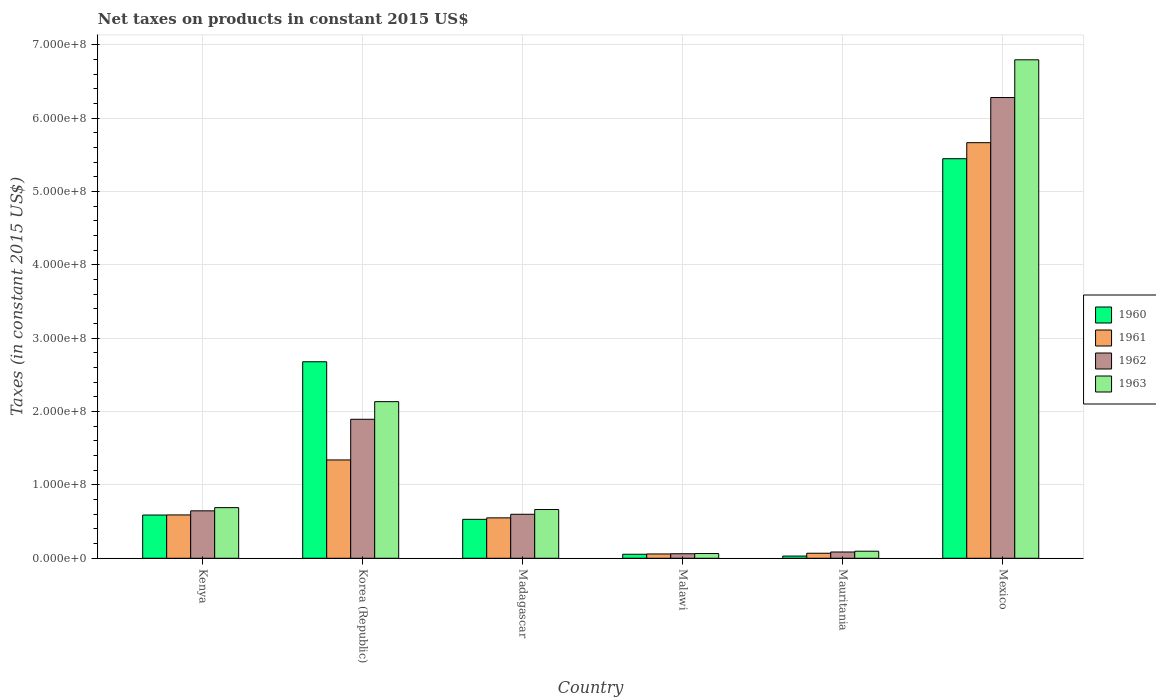How many different coloured bars are there?
Offer a terse response. 4. How many groups of bars are there?
Provide a short and direct response. 6. How many bars are there on the 2nd tick from the right?
Provide a succinct answer. 4. In how many cases, is the number of bars for a given country not equal to the number of legend labels?
Your answer should be compact. 0. What is the net taxes on products in 1963 in Malawi?
Offer a terse response. 6.44e+06. Across all countries, what is the maximum net taxes on products in 1960?
Give a very brief answer. 5.45e+08. Across all countries, what is the minimum net taxes on products in 1963?
Your answer should be compact. 6.44e+06. In which country was the net taxes on products in 1963 maximum?
Your answer should be very brief. Mexico. In which country was the net taxes on products in 1962 minimum?
Give a very brief answer. Malawi. What is the total net taxes on products in 1962 in the graph?
Ensure brevity in your answer.  9.57e+08. What is the difference between the net taxes on products in 1961 in Madagascar and that in Mauritania?
Ensure brevity in your answer.  4.82e+07. What is the difference between the net taxes on products in 1960 in Mexico and the net taxes on products in 1961 in Malawi?
Provide a succinct answer. 5.39e+08. What is the average net taxes on products in 1963 per country?
Provide a short and direct response. 1.74e+08. What is the difference between the net taxes on products of/in 1962 and net taxes on products of/in 1963 in Mauritania?
Provide a short and direct response. -1.07e+06. In how many countries, is the net taxes on products in 1962 greater than 200000000 US$?
Give a very brief answer. 1. What is the ratio of the net taxes on products in 1963 in Kenya to that in Madagascar?
Provide a succinct answer. 1.04. Is the net taxes on products in 1961 in Malawi less than that in Mexico?
Provide a succinct answer. Yes. Is the difference between the net taxes on products in 1962 in Korea (Republic) and Mexico greater than the difference between the net taxes on products in 1963 in Korea (Republic) and Mexico?
Keep it short and to the point. Yes. What is the difference between the highest and the second highest net taxes on products in 1961?
Ensure brevity in your answer.  -7.49e+07. What is the difference between the highest and the lowest net taxes on products in 1962?
Make the answer very short. 6.22e+08. In how many countries, is the net taxes on products in 1960 greater than the average net taxes on products in 1960 taken over all countries?
Your answer should be very brief. 2. What does the 1st bar from the left in Mexico represents?
Your answer should be very brief. 1960. How many bars are there?
Ensure brevity in your answer.  24. Are all the bars in the graph horizontal?
Keep it short and to the point. No. Does the graph contain grids?
Provide a succinct answer. Yes. Where does the legend appear in the graph?
Give a very brief answer. Center right. What is the title of the graph?
Your answer should be very brief. Net taxes on products in constant 2015 US$. What is the label or title of the X-axis?
Offer a very short reply. Country. What is the label or title of the Y-axis?
Your response must be concise. Taxes (in constant 2015 US$). What is the Taxes (in constant 2015 US$) in 1960 in Kenya?
Keep it short and to the point. 5.89e+07. What is the Taxes (in constant 2015 US$) in 1961 in Kenya?
Provide a succinct answer. 5.91e+07. What is the Taxes (in constant 2015 US$) in 1962 in Kenya?
Offer a terse response. 6.47e+07. What is the Taxes (in constant 2015 US$) of 1963 in Kenya?
Offer a terse response. 6.90e+07. What is the Taxes (in constant 2015 US$) in 1960 in Korea (Republic)?
Provide a short and direct response. 2.68e+08. What is the Taxes (in constant 2015 US$) in 1961 in Korea (Republic)?
Keep it short and to the point. 1.34e+08. What is the Taxes (in constant 2015 US$) of 1962 in Korea (Republic)?
Offer a very short reply. 1.89e+08. What is the Taxes (in constant 2015 US$) in 1963 in Korea (Republic)?
Provide a succinct answer. 2.13e+08. What is the Taxes (in constant 2015 US$) in 1960 in Madagascar?
Provide a succinct answer. 5.31e+07. What is the Taxes (in constant 2015 US$) of 1961 in Madagascar?
Ensure brevity in your answer.  5.51e+07. What is the Taxes (in constant 2015 US$) in 1962 in Madagascar?
Your answer should be very brief. 6.00e+07. What is the Taxes (in constant 2015 US$) of 1963 in Madagascar?
Your answer should be compact. 6.64e+07. What is the Taxes (in constant 2015 US$) of 1960 in Malawi?
Your answer should be very brief. 5.46e+06. What is the Taxes (in constant 2015 US$) in 1961 in Malawi?
Provide a succinct answer. 5.88e+06. What is the Taxes (in constant 2015 US$) of 1962 in Malawi?
Provide a succinct answer. 6.16e+06. What is the Taxes (in constant 2015 US$) in 1963 in Malawi?
Offer a very short reply. 6.44e+06. What is the Taxes (in constant 2015 US$) of 1960 in Mauritania?
Provide a succinct answer. 3.00e+06. What is the Taxes (in constant 2015 US$) of 1961 in Mauritania?
Your answer should be compact. 6.85e+06. What is the Taxes (in constant 2015 US$) in 1962 in Mauritania?
Ensure brevity in your answer.  8.56e+06. What is the Taxes (in constant 2015 US$) in 1963 in Mauritania?
Your answer should be very brief. 9.63e+06. What is the Taxes (in constant 2015 US$) of 1960 in Mexico?
Make the answer very short. 5.45e+08. What is the Taxes (in constant 2015 US$) in 1961 in Mexico?
Your response must be concise. 5.66e+08. What is the Taxes (in constant 2015 US$) of 1962 in Mexico?
Give a very brief answer. 6.28e+08. What is the Taxes (in constant 2015 US$) in 1963 in Mexico?
Provide a succinct answer. 6.79e+08. Across all countries, what is the maximum Taxes (in constant 2015 US$) of 1960?
Keep it short and to the point. 5.45e+08. Across all countries, what is the maximum Taxes (in constant 2015 US$) of 1961?
Offer a very short reply. 5.66e+08. Across all countries, what is the maximum Taxes (in constant 2015 US$) of 1962?
Your response must be concise. 6.28e+08. Across all countries, what is the maximum Taxes (in constant 2015 US$) in 1963?
Your answer should be compact. 6.79e+08. Across all countries, what is the minimum Taxes (in constant 2015 US$) of 1960?
Offer a terse response. 3.00e+06. Across all countries, what is the minimum Taxes (in constant 2015 US$) of 1961?
Your response must be concise. 5.88e+06. Across all countries, what is the minimum Taxes (in constant 2015 US$) of 1962?
Give a very brief answer. 6.16e+06. Across all countries, what is the minimum Taxes (in constant 2015 US$) of 1963?
Ensure brevity in your answer.  6.44e+06. What is the total Taxes (in constant 2015 US$) in 1960 in the graph?
Your answer should be very brief. 9.33e+08. What is the total Taxes (in constant 2015 US$) of 1961 in the graph?
Provide a short and direct response. 8.27e+08. What is the total Taxes (in constant 2015 US$) in 1962 in the graph?
Offer a terse response. 9.57e+08. What is the total Taxes (in constant 2015 US$) in 1963 in the graph?
Provide a succinct answer. 1.04e+09. What is the difference between the Taxes (in constant 2015 US$) of 1960 in Kenya and that in Korea (Republic)?
Offer a terse response. -2.09e+08. What is the difference between the Taxes (in constant 2015 US$) of 1961 in Kenya and that in Korea (Republic)?
Your answer should be very brief. -7.49e+07. What is the difference between the Taxes (in constant 2015 US$) of 1962 in Kenya and that in Korea (Republic)?
Your response must be concise. -1.25e+08. What is the difference between the Taxes (in constant 2015 US$) in 1963 in Kenya and that in Korea (Republic)?
Make the answer very short. -1.44e+08. What is the difference between the Taxes (in constant 2015 US$) of 1960 in Kenya and that in Madagascar?
Provide a short and direct response. 5.86e+06. What is the difference between the Taxes (in constant 2015 US$) of 1961 in Kenya and that in Madagascar?
Make the answer very short. 3.97e+06. What is the difference between the Taxes (in constant 2015 US$) of 1962 in Kenya and that in Madagascar?
Keep it short and to the point. 4.70e+06. What is the difference between the Taxes (in constant 2015 US$) of 1963 in Kenya and that in Madagascar?
Offer a terse response. 2.58e+06. What is the difference between the Taxes (in constant 2015 US$) of 1960 in Kenya and that in Malawi?
Keep it short and to the point. 5.35e+07. What is the difference between the Taxes (in constant 2015 US$) in 1961 in Kenya and that in Malawi?
Your response must be concise. 5.32e+07. What is the difference between the Taxes (in constant 2015 US$) of 1962 in Kenya and that in Malawi?
Provide a succinct answer. 5.85e+07. What is the difference between the Taxes (in constant 2015 US$) of 1963 in Kenya and that in Malawi?
Your answer should be very brief. 6.26e+07. What is the difference between the Taxes (in constant 2015 US$) of 1960 in Kenya and that in Mauritania?
Your answer should be compact. 5.59e+07. What is the difference between the Taxes (in constant 2015 US$) in 1961 in Kenya and that in Mauritania?
Ensure brevity in your answer.  5.22e+07. What is the difference between the Taxes (in constant 2015 US$) in 1962 in Kenya and that in Mauritania?
Provide a short and direct response. 5.61e+07. What is the difference between the Taxes (in constant 2015 US$) of 1963 in Kenya and that in Mauritania?
Your response must be concise. 5.94e+07. What is the difference between the Taxes (in constant 2015 US$) of 1960 in Kenya and that in Mexico?
Your answer should be very brief. -4.86e+08. What is the difference between the Taxes (in constant 2015 US$) of 1961 in Kenya and that in Mexico?
Make the answer very short. -5.07e+08. What is the difference between the Taxes (in constant 2015 US$) in 1962 in Kenya and that in Mexico?
Ensure brevity in your answer.  -5.63e+08. What is the difference between the Taxes (in constant 2015 US$) of 1963 in Kenya and that in Mexico?
Provide a short and direct response. -6.10e+08. What is the difference between the Taxes (in constant 2015 US$) of 1960 in Korea (Republic) and that in Madagascar?
Keep it short and to the point. 2.15e+08. What is the difference between the Taxes (in constant 2015 US$) of 1961 in Korea (Republic) and that in Madagascar?
Your answer should be compact. 7.89e+07. What is the difference between the Taxes (in constant 2015 US$) of 1962 in Korea (Republic) and that in Madagascar?
Your response must be concise. 1.29e+08. What is the difference between the Taxes (in constant 2015 US$) in 1963 in Korea (Republic) and that in Madagascar?
Give a very brief answer. 1.47e+08. What is the difference between the Taxes (in constant 2015 US$) of 1960 in Korea (Republic) and that in Malawi?
Make the answer very short. 2.62e+08. What is the difference between the Taxes (in constant 2015 US$) in 1961 in Korea (Republic) and that in Malawi?
Ensure brevity in your answer.  1.28e+08. What is the difference between the Taxes (in constant 2015 US$) of 1962 in Korea (Republic) and that in Malawi?
Offer a very short reply. 1.83e+08. What is the difference between the Taxes (in constant 2015 US$) of 1963 in Korea (Republic) and that in Malawi?
Your answer should be compact. 2.07e+08. What is the difference between the Taxes (in constant 2015 US$) of 1960 in Korea (Republic) and that in Mauritania?
Provide a succinct answer. 2.65e+08. What is the difference between the Taxes (in constant 2015 US$) in 1961 in Korea (Republic) and that in Mauritania?
Give a very brief answer. 1.27e+08. What is the difference between the Taxes (in constant 2015 US$) in 1962 in Korea (Republic) and that in Mauritania?
Offer a very short reply. 1.81e+08. What is the difference between the Taxes (in constant 2015 US$) of 1963 in Korea (Republic) and that in Mauritania?
Give a very brief answer. 2.04e+08. What is the difference between the Taxes (in constant 2015 US$) in 1960 in Korea (Republic) and that in Mexico?
Your answer should be compact. -2.77e+08. What is the difference between the Taxes (in constant 2015 US$) in 1961 in Korea (Republic) and that in Mexico?
Your response must be concise. -4.32e+08. What is the difference between the Taxes (in constant 2015 US$) in 1962 in Korea (Republic) and that in Mexico?
Your answer should be compact. -4.38e+08. What is the difference between the Taxes (in constant 2015 US$) of 1963 in Korea (Republic) and that in Mexico?
Make the answer very short. -4.66e+08. What is the difference between the Taxes (in constant 2015 US$) in 1960 in Madagascar and that in Malawi?
Your response must be concise. 4.76e+07. What is the difference between the Taxes (in constant 2015 US$) in 1961 in Madagascar and that in Malawi?
Give a very brief answer. 4.92e+07. What is the difference between the Taxes (in constant 2015 US$) of 1962 in Madagascar and that in Malawi?
Give a very brief answer. 5.38e+07. What is the difference between the Taxes (in constant 2015 US$) in 1963 in Madagascar and that in Malawi?
Keep it short and to the point. 6.00e+07. What is the difference between the Taxes (in constant 2015 US$) in 1960 in Madagascar and that in Mauritania?
Give a very brief answer. 5.01e+07. What is the difference between the Taxes (in constant 2015 US$) in 1961 in Madagascar and that in Mauritania?
Ensure brevity in your answer.  4.82e+07. What is the difference between the Taxes (in constant 2015 US$) in 1962 in Madagascar and that in Mauritania?
Provide a short and direct response. 5.14e+07. What is the difference between the Taxes (in constant 2015 US$) in 1963 in Madagascar and that in Mauritania?
Offer a terse response. 5.68e+07. What is the difference between the Taxes (in constant 2015 US$) of 1960 in Madagascar and that in Mexico?
Ensure brevity in your answer.  -4.91e+08. What is the difference between the Taxes (in constant 2015 US$) in 1961 in Madagascar and that in Mexico?
Make the answer very short. -5.11e+08. What is the difference between the Taxes (in constant 2015 US$) in 1962 in Madagascar and that in Mexico?
Provide a succinct answer. -5.68e+08. What is the difference between the Taxes (in constant 2015 US$) in 1963 in Madagascar and that in Mexico?
Ensure brevity in your answer.  -6.13e+08. What is the difference between the Taxes (in constant 2015 US$) of 1960 in Malawi and that in Mauritania?
Make the answer very short. 2.46e+06. What is the difference between the Taxes (in constant 2015 US$) in 1961 in Malawi and that in Mauritania?
Your answer should be compact. -9.67e+05. What is the difference between the Taxes (in constant 2015 US$) of 1962 in Malawi and that in Mauritania?
Your answer should be compact. -2.40e+06. What is the difference between the Taxes (in constant 2015 US$) of 1963 in Malawi and that in Mauritania?
Make the answer very short. -3.19e+06. What is the difference between the Taxes (in constant 2015 US$) of 1960 in Malawi and that in Mexico?
Make the answer very short. -5.39e+08. What is the difference between the Taxes (in constant 2015 US$) in 1961 in Malawi and that in Mexico?
Make the answer very short. -5.61e+08. What is the difference between the Taxes (in constant 2015 US$) in 1962 in Malawi and that in Mexico?
Your response must be concise. -6.22e+08. What is the difference between the Taxes (in constant 2015 US$) in 1963 in Malawi and that in Mexico?
Ensure brevity in your answer.  -6.73e+08. What is the difference between the Taxes (in constant 2015 US$) in 1960 in Mauritania and that in Mexico?
Keep it short and to the point. -5.42e+08. What is the difference between the Taxes (in constant 2015 US$) in 1961 in Mauritania and that in Mexico?
Give a very brief answer. -5.60e+08. What is the difference between the Taxes (in constant 2015 US$) of 1962 in Mauritania and that in Mexico?
Offer a very short reply. -6.19e+08. What is the difference between the Taxes (in constant 2015 US$) in 1963 in Mauritania and that in Mexico?
Your response must be concise. -6.70e+08. What is the difference between the Taxes (in constant 2015 US$) in 1960 in Kenya and the Taxes (in constant 2015 US$) in 1961 in Korea (Republic)?
Make the answer very short. -7.51e+07. What is the difference between the Taxes (in constant 2015 US$) of 1960 in Kenya and the Taxes (in constant 2015 US$) of 1962 in Korea (Republic)?
Provide a succinct answer. -1.31e+08. What is the difference between the Taxes (in constant 2015 US$) of 1960 in Kenya and the Taxes (in constant 2015 US$) of 1963 in Korea (Republic)?
Give a very brief answer. -1.55e+08. What is the difference between the Taxes (in constant 2015 US$) in 1961 in Kenya and the Taxes (in constant 2015 US$) in 1962 in Korea (Republic)?
Provide a short and direct response. -1.30e+08. What is the difference between the Taxes (in constant 2015 US$) in 1961 in Kenya and the Taxes (in constant 2015 US$) in 1963 in Korea (Republic)?
Keep it short and to the point. -1.54e+08. What is the difference between the Taxes (in constant 2015 US$) in 1962 in Kenya and the Taxes (in constant 2015 US$) in 1963 in Korea (Republic)?
Keep it short and to the point. -1.49e+08. What is the difference between the Taxes (in constant 2015 US$) in 1960 in Kenya and the Taxes (in constant 2015 US$) in 1961 in Madagascar?
Your response must be concise. 3.83e+06. What is the difference between the Taxes (in constant 2015 US$) of 1960 in Kenya and the Taxes (in constant 2015 US$) of 1962 in Madagascar?
Make the answer very short. -1.03e+06. What is the difference between the Taxes (in constant 2015 US$) of 1960 in Kenya and the Taxes (in constant 2015 US$) of 1963 in Madagascar?
Offer a terse response. -7.51e+06. What is the difference between the Taxes (in constant 2015 US$) of 1961 in Kenya and the Taxes (in constant 2015 US$) of 1962 in Madagascar?
Make the answer very short. -8.90e+05. What is the difference between the Taxes (in constant 2015 US$) in 1961 in Kenya and the Taxes (in constant 2015 US$) in 1963 in Madagascar?
Ensure brevity in your answer.  -7.37e+06. What is the difference between the Taxes (in constant 2015 US$) in 1962 in Kenya and the Taxes (in constant 2015 US$) in 1963 in Madagascar?
Make the answer very short. -1.79e+06. What is the difference between the Taxes (in constant 2015 US$) in 1960 in Kenya and the Taxes (in constant 2015 US$) in 1961 in Malawi?
Ensure brevity in your answer.  5.30e+07. What is the difference between the Taxes (in constant 2015 US$) of 1960 in Kenya and the Taxes (in constant 2015 US$) of 1962 in Malawi?
Keep it short and to the point. 5.28e+07. What is the difference between the Taxes (in constant 2015 US$) of 1960 in Kenya and the Taxes (in constant 2015 US$) of 1963 in Malawi?
Offer a terse response. 5.25e+07. What is the difference between the Taxes (in constant 2015 US$) in 1961 in Kenya and the Taxes (in constant 2015 US$) in 1962 in Malawi?
Ensure brevity in your answer.  5.29e+07. What is the difference between the Taxes (in constant 2015 US$) in 1961 in Kenya and the Taxes (in constant 2015 US$) in 1963 in Malawi?
Give a very brief answer. 5.26e+07. What is the difference between the Taxes (in constant 2015 US$) in 1962 in Kenya and the Taxes (in constant 2015 US$) in 1963 in Malawi?
Provide a succinct answer. 5.82e+07. What is the difference between the Taxes (in constant 2015 US$) of 1960 in Kenya and the Taxes (in constant 2015 US$) of 1961 in Mauritania?
Provide a short and direct response. 5.21e+07. What is the difference between the Taxes (in constant 2015 US$) in 1960 in Kenya and the Taxes (in constant 2015 US$) in 1962 in Mauritania?
Make the answer very short. 5.04e+07. What is the difference between the Taxes (in constant 2015 US$) in 1960 in Kenya and the Taxes (in constant 2015 US$) in 1963 in Mauritania?
Your response must be concise. 4.93e+07. What is the difference between the Taxes (in constant 2015 US$) of 1961 in Kenya and the Taxes (in constant 2015 US$) of 1962 in Mauritania?
Keep it short and to the point. 5.05e+07. What is the difference between the Taxes (in constant 2015 US$) in 1961 in Kenya and the Taxes (in constant 2015 US$) in 1963 in Mauritania?
Offer a very short reply. 4.94e+07. What is the difference between the Taxes (in constant 2015 US$) in 1962 in Kenya and the Taxes (in constant 2015 US$) in 1963 in Mauritania?
Ensure brevity in your answer.  5.50e+07. What is the difference between the Taxes (in constant 2015 US$) of 1960 in Kenya and the Taxes (in constant 2015 US$) of 1961 in Mexico?
Your response must be concise. -5.07e+08. What is the difference between the Taxes (in constant 2015 US$) in 1960 in Kenya and the Taxes (in constant 2015 US$) in 1962 in Mexico?
Offer a terse response. -5.69e+08. What is the difference between the Taxes (in constant 2015 US$) of 1960 in Kenya and the Taxes (in constant 2015 US$) of 1963 in Mexico?
Provide a short and direct response. -6.20e+08. What is the difference between the Taxes (in constant 2015 US$) in 1961 in Kenya and the Taxes (in constant 2015 US$) in 1962 in Mexico?
Your response must be concise. -5.69e+08. What is the difference between the Taxes (in constant 2015 US$) of 1961 in Kenya and the Taxes (in constant 2015 US$) of 1963 in Mexico?
Offer a terse response. -6.20e+08. What is the difference between the Taxes (in constant 2015 US$) of 1962 in Kenya and the Taxes (in constant 2015 US$) of 1963 in Mexico?
Give a very brief answer. -6.15e+08. What is the difference between the Taxes (in constant 2015 US$) of 1960 in Korea (Republic) and the Taxes (in constant 2015 US$) of 1961 in Madagascar?
Give a very brief answer. 2.13e+08. What is the difference between the Taxes (in constant 2015 US$) of 1960 in Korea (Republic) and the Taxes (in constant 2015 US$) of 1962 in Madagascar?
Your response must be concise. 2.08e+08. What is the difference between the Taxes (in constant 2015 US$) of 1960 in Korea (Republic) and the Taxes (in constant 2015 US$) of 1963 in Madagascar?
Provide a succinct answer. 2.01e+08. What is the difference between the Taxes (in constant 2015 US$) of 1961 in Korea (Republic) and the Taxes (in constant 2015 US$) of 1962 in Madagascar?
Offer a terse response. 7.41e+07. What is the difference between the Taxes (in constant 2015 US$) of 1961 in Korea (Republic) and the Taxes (in constant 2015 US$) of 1963 in Madagascar?
Provide a succinct answer. 6.76e+07. What is the difference between the Taxes (in constant 2015 US$) of 1962 in Korea (Republic) and the Taxes (in constant 2015 US$) of 1963 in Madagascar?
Offer a very short reply. 1.23e+08. What is the difference between the Taxes (in constant 2015 US$) of 1960 in Korea (Republic) and the Taxes (in constant 2015 US$) of 1961 in Malawi?
Give a very brief answer. 2.62e+08. What is the difference between the Taxes (in constant 2015 US$) in 1960 in Korea (Republic) and the Taxes (in constant 2015 US$) in 1962 in Malawi?
Your response must be concise. 2.62e+08. What is the difference between the Taxes (in constant 2015 US$) in 1960 in Korea (Republic) and the Taxes (in constant 2015 US$) in 1963 in Malawi?
Make the answer very short. 2.61e+08. What is the difference between the Taxes (in constant 2015 US$) of 1961 in Korea (Republic) and the Taxes (in constant 2015 US$) of 1962 in Malawi?
Give a very brief answer. 1.28e+08. What is the difference between the Taxes (in constant 2015 US$) of 1961 in Korea (Republic) and the Taxes (in constant 2015 US$) of 1963 in Malawi?
Ensure brevity in your answer.  1.28e+08. What is the difference between the Taxes (in constant 2015 US$) of 1962 in Korea (Republic) and the Taxes (in constant 2015 US$) of 1963 in Malawi?
Offer a very short reply. 1.83e+08. What is the difference between the Taxes (in constant 2015 US$) of 1960 in Korea (Republic) and the Taxes (in constant 2015 US$) of 1961 in Mauritania?
Your response must be concise. 2.61e+08. What is the difference between the Taxes (in constant 2015 US$) in 1960 in Korea (Republic) and the Taxes (in constant 2015 US$) in 1962 in Mauritania?
Your answer should be compact. 2.59e+08. What is the difference between the Taxes (in constant 2015 US$) in 1960 in Korea (Republic) and the Taxes (in constant 2015 US$) in 1963 in Mauritania?
Your answer should be compact. 2.58e+08. What is the difference between the Taxes (in constant 2015 US$) of 1961 in Korea (Republic) and the Taxes (in constant 2015 US$) of 1962 in Mauritania?
Your answer should be compact. 1.25e+08. What is the difference between the Taxes (in constant 2015 US$) in 1961 in Korea (Republic) and the Taxes (in constant 2015 US$) in 1963 in Mauritania?
Your answer should be very brief. 1.24e+08. What is the difference between the Taxes (in constant 2015 US$) of 1962 in Korea (Republic) and the Taxes (in constant 2015 US$) of 1963 in Mauritania?
Offer a very short reply. 1.80e+08. What is the difference between the Taxes (in constant 2015 US$) in 1960 in Korea (Republic) and the Taxes (in constant 2015 US$) in 1961 in Mexico?
Make the answer very short. -2.99e+08. What is the difference between the Taxes (in constant 2015 US$) in 1960 in Korea (Republic) and the Taxes (in constant 2015 US$) in 1962 in Mexico?
Give a very brief answer. -3.60e+08. What is the difference between the Taxes (in constant 2015 US$) in 1960 in Korea (Republic) and the Taxes (in constant 2015 US$) in 1963 in Mexico?
Your answer should be very brief. -4.12e+08. What is the difference between the Taxes (in constant 2015 US$) in 1961 in Korea (Republic) and the Taxes (in constant 2015 US$) in 1962 in Mexico?
Offer a terse response. -4.94e+08. What is the difference between the Taxes (in constant 2015 US$) in 1961 in Korea (Republic) and the Taxes (in constant 2015 US$) in 1963 in Mexico?
Ensure brevity in your answer.  -5.45e+08. What is the difference between the Taxes (in constant 2015 US$) in 1962 in Korea (Republic) and the Taxes (in constant 2015 US$) in 1963 in Mexico?
Your answer should be very brief. -4.90e+08. What is the difference between the Taxes (in constant 2015 US$) in 1960 in Madagascar and the Taxes (in constant 2015 US$) in 1961 in Malawi?
Your answer should be compact. 4.72e+07. What is the difference between the Taxes (in constant 2015 US$) in 1960 in Madagascar and the Taxes (in constant 2015 US$) in 1962 in Malawi?
Give a very brief answer. 4.69e+07. What is the difference between the Taxes (in constant 2015 US$) of 1960 in Madagascar and the Taxes (in constant 2015 US$) of 1963 in Malawi?
Your answer should be compact. 4.66e+07. What is the difference between the Taxes (in constant 2015 US$) in 1961 in Madagascar and the Taxes (in constant 2015 US$) in 1962 in Malawi?
Your answer should be very brief. 4.89e+07. What is the difference between the Taxes (in constant 2015 US$) of 1961 in Madagascar and the Taxes (in constant 2015 US$) of 1963 in Malawi?
Offer a terse response. 4.87e+07. What is the difference between the Taxes (in constant 2015 US$) in 1962 in Madagascar and the Taxes (in constant 2015 US$) in 1963 in Malawi?
Ensure brevity in your answer.  5.35e+07. What is the difference between the Taxes (in constant 2015 US$) of 1960 in Madagascar and the Taxes (in constant 2015 US$) of 1961 in Mauritania?
Give a very brief answer. 4.62e+07. What is the difference between the Taxes (in constant 2015 US$) of 1960 in Madagascar and the Taxes (in constant 2015 US$) of 1962 in Mauritania?
Give a very brief answer. 4.45e+07. What is the difference between the Taxes (in constant 2015 US$) of 1960 in Madagascar and the Taxes (in constant 2015 US$) of 1963 in Mauritania?
Make the answer very short. 4.34e+07. What is the difference between the Taxes (in constant 2015 US$) of 1961 in Madagascar and the Taxes (in constant 2015 US$) of 1962 in Mauritania?
Give a very brief answer. 4.65e+07. What is the difference between the Taxes (in constant 2015 US$) of 1961 in Madagascar and the Taxes (in constant 2015 US$) of 1963 in Mauritania?
Your answer should be very brief. 4.55e+07. What is the difference between the Taxes (in constant 2015 US$) of 1962 in Madagascar and the Taxes (in constant 2015 US$) of 1963 in Mauritania?
Give a very brief answer. 5.03e+07. What is the difference between the Taxes (in constant 2015 US$) in 1960 in Madagascar and the Taxes (in constant 2015 US$) in 1961 in Mexico?
Provide a succinct answer. -5.13e+08. What is the difference between the Taxes (in constant 2015 US$) of 1960 in Madagascar and the Taxes (in constant 2015 US$) of 1962 in Mexico?
Give a very brief answer. -5.75e+08. What is the difference between the Taxes (in constant 2015 US$) in 1960 in Madagascar and the Taxes (in constant 2015 US$) in 1963 in Mexico?
Your answer should be very brief. -6.26e+08. What is the difference between the Taxes (in constant 2015 US$) in 1961 in Madagascar and the Taxes (in constant 2015 US$) in 1962 in Mexico?
Ensure brevity in your answer.  -5.73e+08. What is the difference between the Taxes (in constant 2015 US$) in 1961 in Madagascar and the Taxes (in constant 2015 US$) in 1963 in Mexico?
Offer a very short reply. -6.24e+08. What is the difference between the Taxes (in constant 2015 US$) of 1962 in Madagascar and the Taxes (in constant 2015 US$) of 1963 in Mexico?
Provide a succinct answer. -6.19e+08. What is the difference between the Taxes (in constant 2015 US$) in 1960 in Malawi and the Taxes (in constant 2015 US$) in 1961 in Mauritania?
Provide a succinct answer. -1.39e+06. What is the difference between the Taxes (in constant 2015 US$) of 1960 in Malawi and the Taxes (in constant 2015 US$) of 1962 in Mauritania?
Your answer should be compact. -3.10e+06. What is the difference between the Taxes (in constant 2015 US$) in 1960 in Malawi and the Taxes (in constant 2015 US$) in 1963 in Mauritania?
Provide a short and direct response. -4.17e+06. What is the difference between the Taxes (in constant 2015 US$) in 1961 in Malawi and the Taxes (in constant 2015 US$) in 1962 in Mauritania?
Your answer should be very brief. -2.68e+06. What is the difference between the Taxes (in constant 2015 US$) in 1961 in Malawi and the Taxes (in constant 2015 US$) in 1963 in Mauritania?
Offer a very short reply. -3.75e+06. What is the difference between the Taxes (in constant 2015 US$) in 1962 in Malawi and the Taxes (in constant 2015 US$) in 1963 in Mauritania?
Make the answer very short. -3.47e+06. What is the difference between the Taxes (in constant 2015 US$) of 1960 in Malawi and the Taxes (in constant 2015 US$) of 1961 in Mexico?
Provide a succinct answer. -5.61e+08. What is the difference between the Taxes (in constant 2015 US$) of 1960 in Malawi and the Taxes (in constant 2015 US$) of 1962 in Mexico?
Offer a terse response. -6.22e+08. What is the difference between the Taxes (in constant 2015 US$) of 1960 in Malawi and the Taxes (in constant 2015 US$) of 1963 in Mexico?
Give a very brief answer. -6.74e+08. What is the difference between the Taxes (in constant 2015 US$) in 1961 in Malawi and the Taxes (in constant 2015 US$) in 1962 in Mexico?
Offer a terse response. -6.22e+08. What is the difference between the Taxes (in constant 2015 US$) in 1961 in Malawi and the Taxes (in constant 2015 US$) in 1963 in Mexico?
Offer a very short reply. -6.73e+08. What is the difference between the Taxes (in constant 2015 US$) of 1962 in Malawi and the Taxes (in constant 2015 US$) of 1963 in Mexico?
Offer a very short reply. -6.73e+08. What is the difference between the Taxes (in constant 2015 US$) of 1960 in Mauritania and the Taxes (in constant 2015 US$) of 1961 in Mexico?
Your answer should be compact. -5.63e+08. What is the difference between the Taxes (in constant 2015 US$) in 1960 in Mauritania and the Taxes (in constant 2015 US$) in 1962 in Mexico?
Keep it short and to the point. -6.25e+08. What is the difference between the Taxes (in constant 2015 US$) in 1960 in Mauritania and the Taxes (in constant 2015 US$) in 1963 in Mexico?
Make the answer very short. -6.76e+08. What is the difference between the Taxes (in constant 2015 US$) in 1961 in Mauritania and the Taxes (in constant 2015 US$) in 1962 in Mexico?
Give a very brief answer. -6.21e+08. What is the difference between the Taxes (in constant 2015 US$) in 1961 in Mauritania and the Taxes (in constant 2015 US$) in 1963 in Mexico?
Provide a short and direct response. -6.73e+08. What is the difference between the Taxes (in constant 2015 US$) of 1962 in Mauritania and the Taxes (in constant 2015 US$) of 1963 in Mexico?
Your response must be concise. -6.71e+08. What is the average Taxes (in constant 2015 US$) in 1960 per country?
Ensure brevity in your answer.  1.55e+08. What is the average Taxes (in constant 2015 US$) of 1961 per country?
Offer a terse response. 1.38e+08. What is the average Taxes (in constant 2015 US$) of 1962 per country?
Your answer should be compact. 1.59e+08. What is the average Taxes (in constant 2015 US$) of 1963 per country?
Your answer should be compact. 1.74e+08. What is the difference between the Taxes (in constant 2015 US$) of 1960 and Taxes (in constant 2015 US$) of 1961 in Kenya?
Keep it short and to the point. -1.40e+05. What is the difference between the Taxes (in constant 2015 US$) of 1960 and Taxes (in constant 2015 US$) of 1962 in Kenya?
Make the answer very short. -5.73e+06. What is the difference between the Taxes (in constant 2015 US$) in 1960 and Taxes (in constant 2015 US$) in 1963 in Kenya?
Ensure brevity in your answer.  -1.01e+07. What is the difference between the Taxes (in constant 2015 US$) of 1961 and Taxes (in constant 2015 US$) of 1962 in Kenya?
Your answer should be compact. -5.59e+06. What is the difference between the Taxes (in constant 2015 US$) in 1961 and Taxes (in constant 2015 US$) in 1963 in Kenya?
Ensure brevity in your answer.  -9.95e+06. What is the difference between the Taxes (in constant 2015 US$) of 1962 and Taxes (in constant 2015 US$) of 1963 in Kenya?
Give a very brief answer. -4.37e+06. What is the difference between the Taxes (in constant 2015 US$) in 1960 and Taxes (in constant 2015 US$) in 1961 in Korea (Republic)?
Offer a terse response. 1.34e+08. What is the difference between the Taxes (in constant 2015 US$) in 1960 and Taxes (in constant 2015 US$) in 1962 in Korea (Republic)?
Your answer should be very brief. 7.84e+07. What is the difference between the Taxes (in constant 2015 US$) of 1960 and Taxes (in constant 2015 US$) of 1963 in Korea (Republic)?
Your answer should be very brief. 5.44e+07. What is the difference between the Taxes (in constant 2015 US$) of 1961 and Taxes (in constant 2015 US$) of 1962 in Korea (Republic)?
Make the answer very short. -5.54e+07. What is the difference between the Taxes (in constant 2015 US$) of 1961 and Taxes (in constant 2015 US$) of 1963 in Korea (Republic)?
Your answer should be very brief. -7.94e+07. What is the difference between the Taxes (in constant 2015 US$) of 1962 and Taxes (in constant 2015 US$) of 1963 in Korea (Republic)?
Your answer should be very brief. -2.40e+07. What is the difference between the Taxes (in constant 2015 US$) in 1960 and Taxes (in constant 2015 US$) in 1961 in Madagascar?
Your answer should be very brief. -2.03e+06. What is the difference between the Taxes (in constant 2015 US$) of 1960 and Taxes (in constant 2015 US$) of 1962 in Madagascar?
Ensure brevity in your answer.  -6.89e+06. What is the difference between the Taxes (in constant 2015 US$) in 1960 and Taxes (in constant 2015 US$) in 1963 in Madagascar?
Ensure brevity in your answer.  -1.34e+07. What is the difference between the Taxes (in constant 2015 US$) of 1961 and Taxes (in constant 2015 US$) of 1962 in Madagascar?
Your response must be concise. -4.86e+06. What is the difference between the Taxes (in constant 2015 US$) of 1961 and Taxes (in constant 2015 US$) of 1963 in Madagascar?
Offer a very short reply. -1.13e+07. What is the difference between the Taxes (in constant 2015 US$) in 1962 and Taxes (in constant 2015 US$) in 1963 in Madagascar?
Your answer should be compact. -6.48e+06. What is the difference between the Taxes (in constant 2015 US$) in 1960 and Taxes (in constant 2015 US$) in 1961 in Malawi?
Make the answer very short. -4.20e+05. What is the difference between the Taxes (in constant 2015 US$) in 1960 and Taxes (in constant 2015 US$) in 1962 in Malawi?
Make the answer very short. -7.00e+05. What is the difference between the Taxes (in constant 2015 US$) of 1960 and Taxes (in constant 2015 US$) of 1963 in Malawi?
Offer a terse response. -9.80e+05. What is the difference between the Taxes (in constant 2015 US$) in 1961 and Taxes (in constant 2015 US$) in 1962 in Malawi?
Your answer should be very brief. -2.80e+05. What is the difference between the Taxes (in constant 2015 US$) of 1961 and Taxes (in constant 2015 US$) of 1963 in Malawi?
Make the answer very short. -5.60e+05. What is the difference between the Taxes (in constant 2015 US$) in 1962 and Taxes (in constant 2015 US$) in 1963 in Malawi?
Your answer should be compact. -2.80e+05. What is the difference between the Taxes (in constant 2015 US$) in 1960 and Taxes (in constant 2015 US$) in 1961 in Mauritania?
Your answer should be very brief. -3.85e+06. What is the difference between the Taxes (in constant 2015 US$) in 1960 and Taxes (in constant 2015 US$) in 1962 in Mauritania?
Keep it short and to the point. -5.56e+06. What is the difference between the Taxes (in constant 2015 US$) in 1960 and Taxes (in constant 2015 US$) in 1963 in Mauritania?
Your answer should be compact. -6.63e+06. What is the difference between the Taxes (in constant 2015 US$) of 1961 and Taxes (in constant 2015 US$) of 1962 in Mauritania?
Your response must be concise. -1.71e+06. What is the difference between the Taxes (in constant 2015 US$) in 1961 and Taxes (in constant 2015 US$) in 1963 in Mauritania?
Give a very brief answer. -2.78e+06. What is the difference between the Taxes (in constant 2015 US$) of 1962 and Taxes (in constant 2015 US$) of 1963 in Mauritania?
Offer a terse response. -1.07e+06. What is the difference between the Taxes (in constant 2015 US$) of 1960 and Taxes (in constant 2015 US$) of 1961 in Mexico?
Ensure brevity in your answer.  -2.18e+07. What is the difference between the Taxes (in constant 2015 US$) in 1960 and Taxes (in constant 2015 US$) in 1962 in Mexico?
Make the answer very short. -8.34e+07. What is the difference between the Taxes (in constant 2015 US$) of 1960 and Taxes (in constant 2015 US$) of 1963 in Mexico?
Your answer should be compact. -1.35e+08. What is the difference between the Taxes (in constant 2015 US$) of 1961 and Taxes (in constant 2015 US$) of 1962 in Mexico?
Ensure brevity in your answer.  -6.15e+07. What is the difference between the Taxes (in constant 2015 US$) in 1961 and Taxes (in constant 2015 US$) in 1963 in Mexico?
Offer a terse response. -1.13e+08. What is the difference between the Taxes (in constant 2015 US$) of 1962 and Taxes (in constant 2015 US$) of 1963 in Mexico?
Give a very brief answer. -5.14e+07. What is the ratio of the Taxes (in constant 2015 US$) of 1960 in Kenya to that in Korea (Republic)?
Make the answer very short. 0.22. What is the ratio of the Taxes (in constant 2015 US$) in 1961 in Kenya to that in Korea (Republic)?
Make the answer very short. 0.44. What is the ratio of the Taxes (in constant 2015 US$) of 1962 in Kenya to that in Korea (Republic)?
Provide a short and direct response. 0.34. What is the ratio of the Taxes (in constant 2015 US$) in 1963 in Kenya to that in Korea (Republic)?
Provide a succinct answer. 0.32. What is the ratio of the Taxes (in constant 2015 US$) in 1960 in Kenya to that in Madagascar?
Give a very brief answer. 1.11. What is the ratio of the Taxes (in constant 2015 US$) in 1961 in Kenya to that in Madagascar?
Provide a succinct answer. 1.07. What is the ratio of the Taxes (in constant 2015 US$) of 1962 in Kenya to that in Madagascar?
Offer a terse response. 1.08. What is the ratio of the Taxes (in constant 2015 US$) in 1963 in Kenya to that in Madagascar?
Offer a very short reply. 1.04. What is the ratio of the Taxes (in constant 2015 US$) of 1960 in Kenya to that in Malawi?
Your response must be concise. 10.79. What is the ratio of the Taxes (in constant 2015 US$) of 1961 in Kenya to that in Malawi?
Make the answer very short. 10.05. What is the ratio of the Taxes (in constant 2015 US$) in 1962 in Kenya to that in Malawi?
Give a very brief answer. 10.5. What is the ratio of the Taxes (in constant 2015 US$) in 1963 in Kenya to that in Malawi?
Make the answer very short. 10.72. What is the ratio of the Taxes (in constant 2015 US$) of 1960 in Kenya to that in Mauritania?
Offer a very short reply. 19.67. What is the ratio of the Taxes (in constant 2015 US$) in 1961 in Kenya to that in Mauritania?
Make the answer very short. 8.63. What is the ratio of the Taxes (in constant 2015 US$) in 1962 in Kenya to that in Mauritania?
Your response must be concise. 7.55. What is the ratio of the Taxes (in constant 2015 US$) in 1963 in Kenya to that in Mauritania?
Offer a terse response. 7.17. What is the ratio of the Taxes (in constant 2015 US$) of 1960 in Kenya to that in Mexico?
Keep it short and to the point. 0.11. What is the ratio of the Taxes (in constant 2015 US$) of 1961 in Kenya to that in Mexico?
Make the answer very short. 0.1. What is the ratio of the Taxes (in constant 2015 US$) in 1962 in Kenya to that in Mexico?
Make the answer very short. 0.1. What is the ratio of the Taxes (in constant 2015 US$) of 1963 in Kenya to that in Mexico?
Keep it short and to the point. 0.1. What is the ratio of the Taxes (in constant 2015 US$) of 1960 in Korea (Republic) to that in Madagascar?
Give a very brief answer. 5.05. What is the ratio of the Taxes (in constant 2015 US$) in 1961 in Korea (Republic) to that in Madagascar?
Your answer should be compact. 2.43. What is the ratio of the Taxes (in constant 2015 US$) in 1962 in Korea (Republic) to that in Madagascar?
Make the answer very short. 3.16. What is the ratio of the Taxes (in constant 2015 US$) of 1963 in Korea (Republic) to that in Madagascar?
Your answer should be compact. 3.21. What is the ratio of the Taxes (in constant 2015 US$) of 1960 in Korea (Republic) to that in Malawi?
Provide a succinct answer. 49.05. What is the ratio of the Taxes (in constant 2015 US$) in 1961 in Korea (Republic) to that in Malawi?
Make the answer very short. 22.79. What is the ratio of the Taxes (in constant 2015 US$) of 1962 in Korea (Republic) to that in Malawi?
Your answer should be very brief. 30.75. What is the ratio of the Taxes (in constant 2015 US$) of 1963 in Korea (Republic) to that in Malawi?
Give a very brief answer. 33.15. What is the ratio of the Taxes (in constant 2015 US$) in 1960 in Korea (Republic) to that in Mauritania?
Give a very brief answer. 89.41. What is the ratio of the Taxes (in constant 2015 US$) of 1961 in Korea (Republic) to that in Mauritania?
Provide a succinct answer. 19.57. What is the ratio of the Taxes (in constant 2015 US$) in 1962 in Korea (Republic) to that in Mauritania?
Provide a succinct answer. 22.13. What is the ratio of the Taxes (in constant 2015 US$) of 1963 in Korea (Republic) to that in Mauritania?
Your response must be concise. 22.17. What is the ratio of the Taxes (in constant 2015 US$) of 1960 in Korea (Republic) to that in Mexico?
Your answer should be very brief. 0.49. What is the ratio of the Taxes (in constant 2015 US$) of 1961 in Korea (Republic) to that in Mexico?
Your response must be concise. 0.24. What is the ratio of the Taxes (in constant 2015 US$) of 1962 in Korea (Republic) to that in Mexico?
Keep it short and to the point. 0.3. What is the ratio of the Taxes (in constant 2015 US$) in 1963 in Korea (Republic) to that in Mexico?
Keep it short and to the point. 0.31. What is the ratio of the Taxes (in constant 2015 US$) in 1960 in Madagascar to that in Malawi?
Offer a terse response. 9.72. What is the ratio of the Taxes (in constant 2015 US$) in 1961 in Madagascar to that in Malawi?
Offer a very short reply. 9.37. What is the ratio of the Taxes (in constant 2015 US$) in 1962 in Madagascar to that in Malawi?
Your response must be concise. 9.73. What is the ratio of the Taxes (in constant 2015 US$) in 1963 in Madagascar to that in Malawi?
Your response must be concise. 10.32. What is the ratio of the Taxes (in constant 2015 US$) in 1960 in Madagascar to that in Mauritania?
Your response must be concise. 17.72. What is the ratio of the Taxes (in constant 2015 US$) of 1961 in Madagascar to that in Mauritania?
Offer a terse response. 8.05. What is the ratio of the Taxes (in constant 2015 US$) in 1962 in Madagascar to that in Mauritania?
Make the answer very short. 7. What is the ratio of the Taxes (in constant 2015 US$) in 1963 in Madagascar to that in Mauritania?
Keep it short and to the point. 6.9. What is the ratio of the Taxes (in constant 2015 US$) of 1960 in Madagascar to that in Mexico?
Make the answer very short. 0.1. What is the ratio of the Taxes (in constant 2015 US$) of 1961 in Madagascar to that in Mexico?
Make the answer very short. 0.1. What is the ratio of the Taxes (in constant 2015 US$) in 1962 in Madagascar to that in Mexico?
Give a very brief answer. 0.1. What is the ratio of the Taxes (in constant 2015 US$) of 1963 in Madagascar to that in Mexico?
Give a very brief answer. 0.1. What is the ratio of the Taxes (in constant 2015 US$) of 1960 in Malawi to that in Mauritania?
Provide a succinct answer. 1.82. What is the ratio of the Taxes (in constant 2015 US$) in 1961 in Malawi to that in Mauritania?
Give a very brief answer. 0.86. What is the ratio of the Taxes (in constant 2015 US$) of 1962 in Malawi to that in Mauritania?
Make the answer very short. 0.72. What is the ratio of the Taxes (in constant 2015 US$) of 1963 in Malawi to that in Mauritania?
Provide a short and direct response. 0.67. What is the ratio of the Taxes (in constant 2015 US$) of 1961 in Malawi to that in Mexico?
Ensure brevity in your answer.  0.01. What is the ratio of the Taxes (in constant 2015 US$) of 1962 in Malawi to that in Mexico?
Your answer should be very brief. 0.01. What is the ratio of the Taxes (in constant 2015 US$) in 1963 in Malawi to that in Mexico?
Ensure brevity in your answer.  0.01. What is the ratio of the Taxes (in constant 2015 US$) of 1960 in Mauritania to that in Mexico?
Make the answer very short. 0.01. What is the ratio of the Taxes (in constant 2015 US$) in 1961 in Mauritania to that in Mexico?
Provide a succinct answer. 0.01. What is the ratio of the Taxes (in constant 2015 US$) of 1962 in Mauritania to that in Mexico?
Give a very brief answer. 0.01. What is the ratio of the Taxes (in constant 2015 US$) of 1963 in Mauritania to that in Mexico?
Offer a very short reply. 0.01. What is the difference between the highest and the second highest Taxes (in constant 2015 US$) in 1960?
Provide a succinct answer. 2.77e+08. What is the difference between the highest and the second highest Taxes (in constant 2015 US$) in 1961?
Give a very brief answer. 4.32e+08. What is the difference between the highest and the second highest Taxes (in constant 2015 US$) of 1962?
Your response must be concise. 4.38e+08. What is the difference between the highest and the second highest Taxes (in constant 2015 US$) in 1963?
Your answer should be very brief. 4.66e+08. What is the difference between the highest and the lowest Taxes (in constant 2015 US$) of 1960?
Give a very brief answer. 5.42e+08. What is the difference between the highest and the lowest Taxes (in constant 2015 US$) of 1961?
Ensure brevity in your answer.  5.61e+08. What is the difference between the highest and the lowest Taxes (in constant 2015 US$) of 1962?
Provide a short and direct response. 6.22e+08. What is the difference between the highest and the lowest Taxes (in constant 2015 US$) of 1963?
Ensure brevity in your answer.  6.73e+08. 